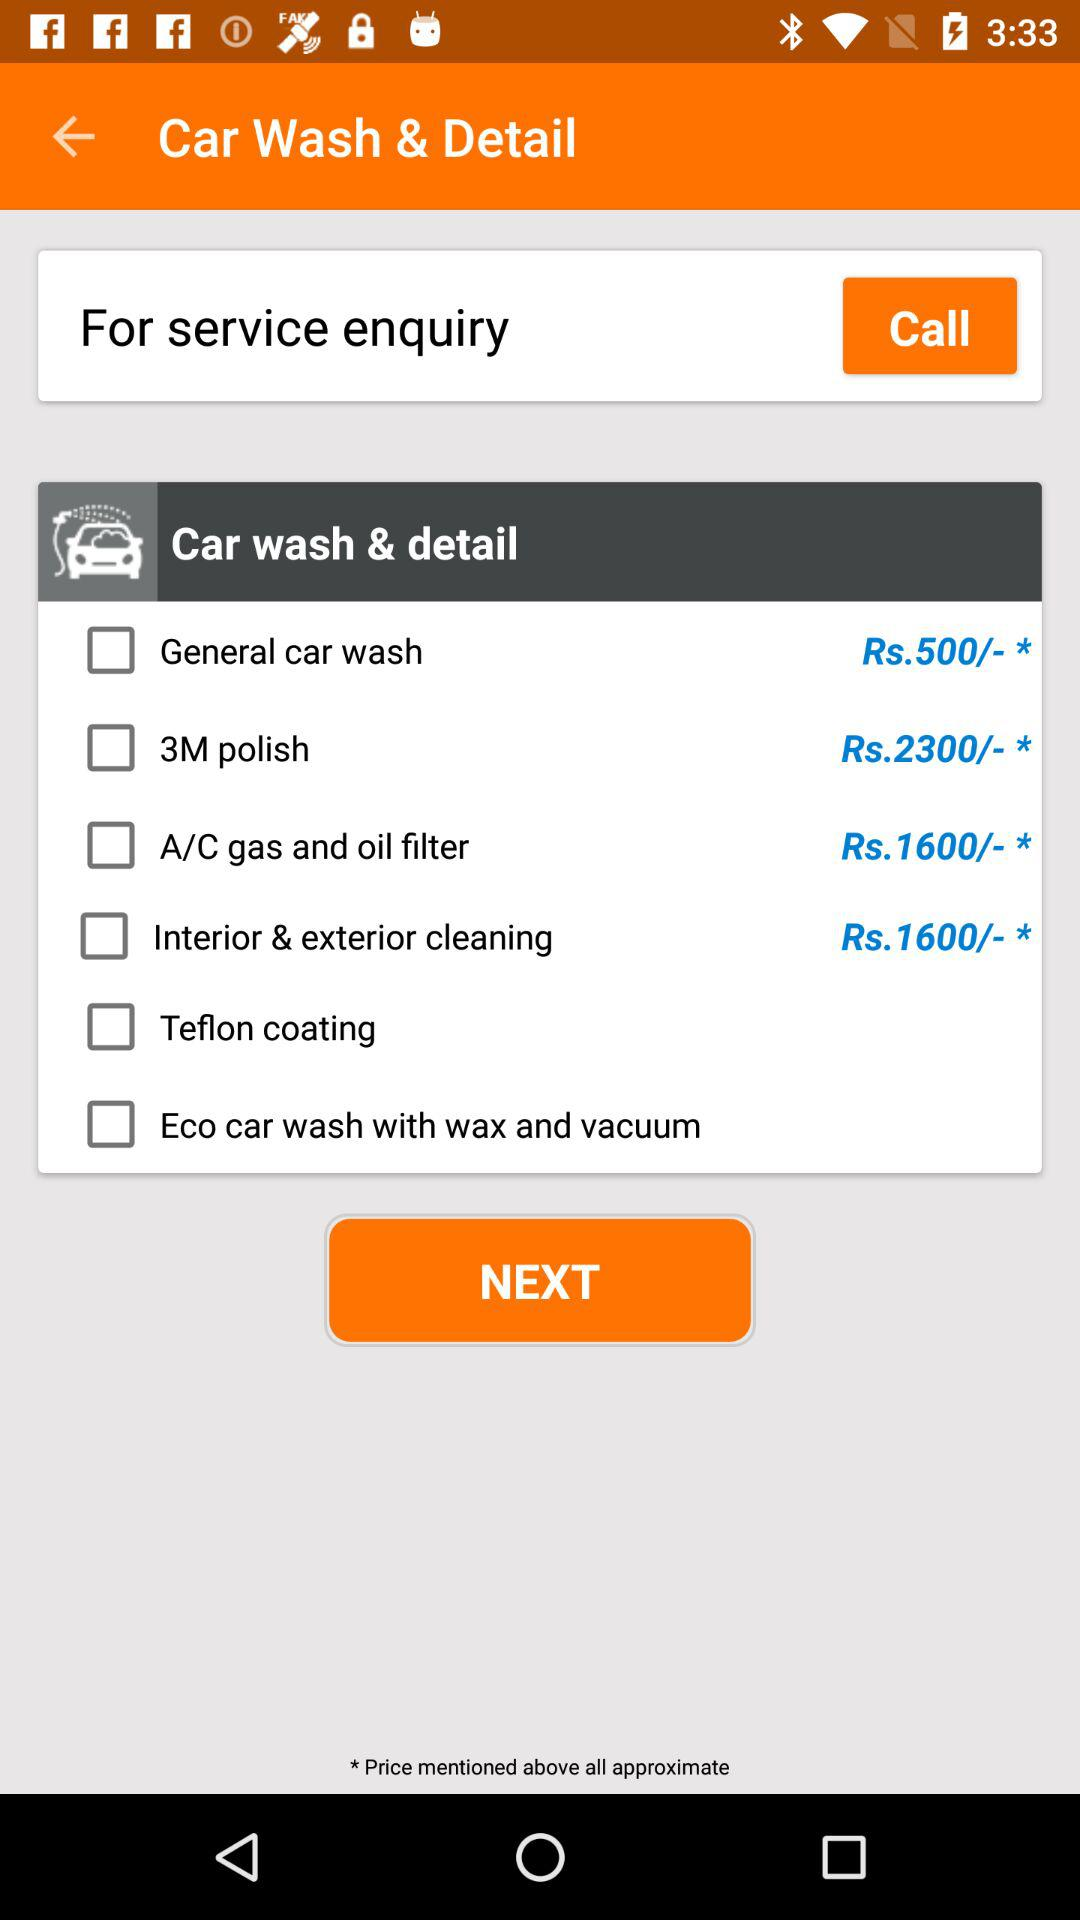What is the current status of "Eco car wash with wax and vacuum"? The current status is "off". 